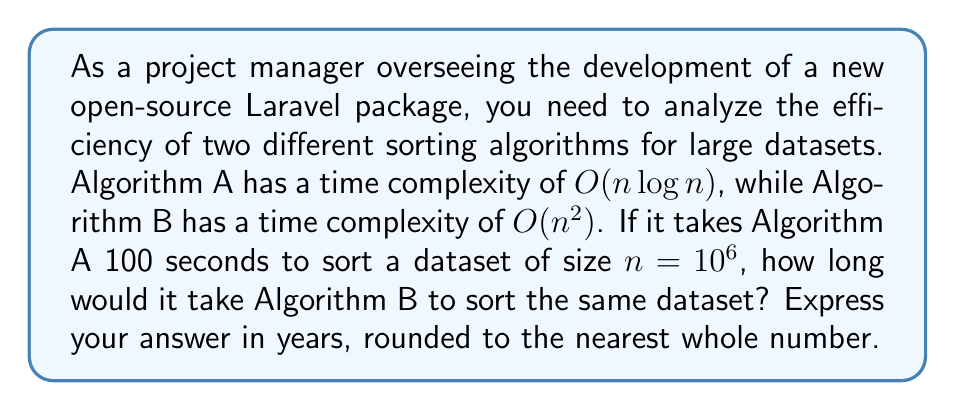Can you answer this question? Let's approach this step-by-step:

1) First, we need to understand the relationship between the two algorithms:
   Algorithm A: $T_A(n) = k_A \cdot n \log n$
   Algorithm B: $T_B(n) = k_B \cdot n^2$
   
   Where $k_A$ and $k_B$ are constants specific to each algorithm.

2) We're given that for Algorithm A, when $n = 10^6$:
   $100 = k_A \cdot 10^6 \log 10^6$

3) We can solve for $k_A$:
   $k_A = \frac{100}{10^6 \log 10^6} = \frac{100}{6 \cdot 10^6} = \frac{1}{60000}$

4) Now, assuming the same hardware is used, we can equate the constants:
   $k_A = k_B = \frac{1}{60000}$

5) For Algorithm B, we can now calculate the time:
   $T_B(10^6) = \frac{1}{60000} \cdot (10^6)^2 = \frac{10^{12}}{60000} = 1.6667 \cdot 10^7$ seconds

6) Convert this to years:
   $\frac{1.6667 \cdot 10^7}{60 \cdot 60 \cdot 24 \cdot 365} \approx 0.5282$ years

7) Rounding to the nearest whole number:
   0.5282 years rounds to 1 year

This analysis demonstrates the significant difference in efficiency between algorithms with logarithmic complexity (like many efficient sorting algorithms) and quadratic complexity for large datasets, which is crucial knowledge for a project manager overseeing software development.
Answer: 1 year 